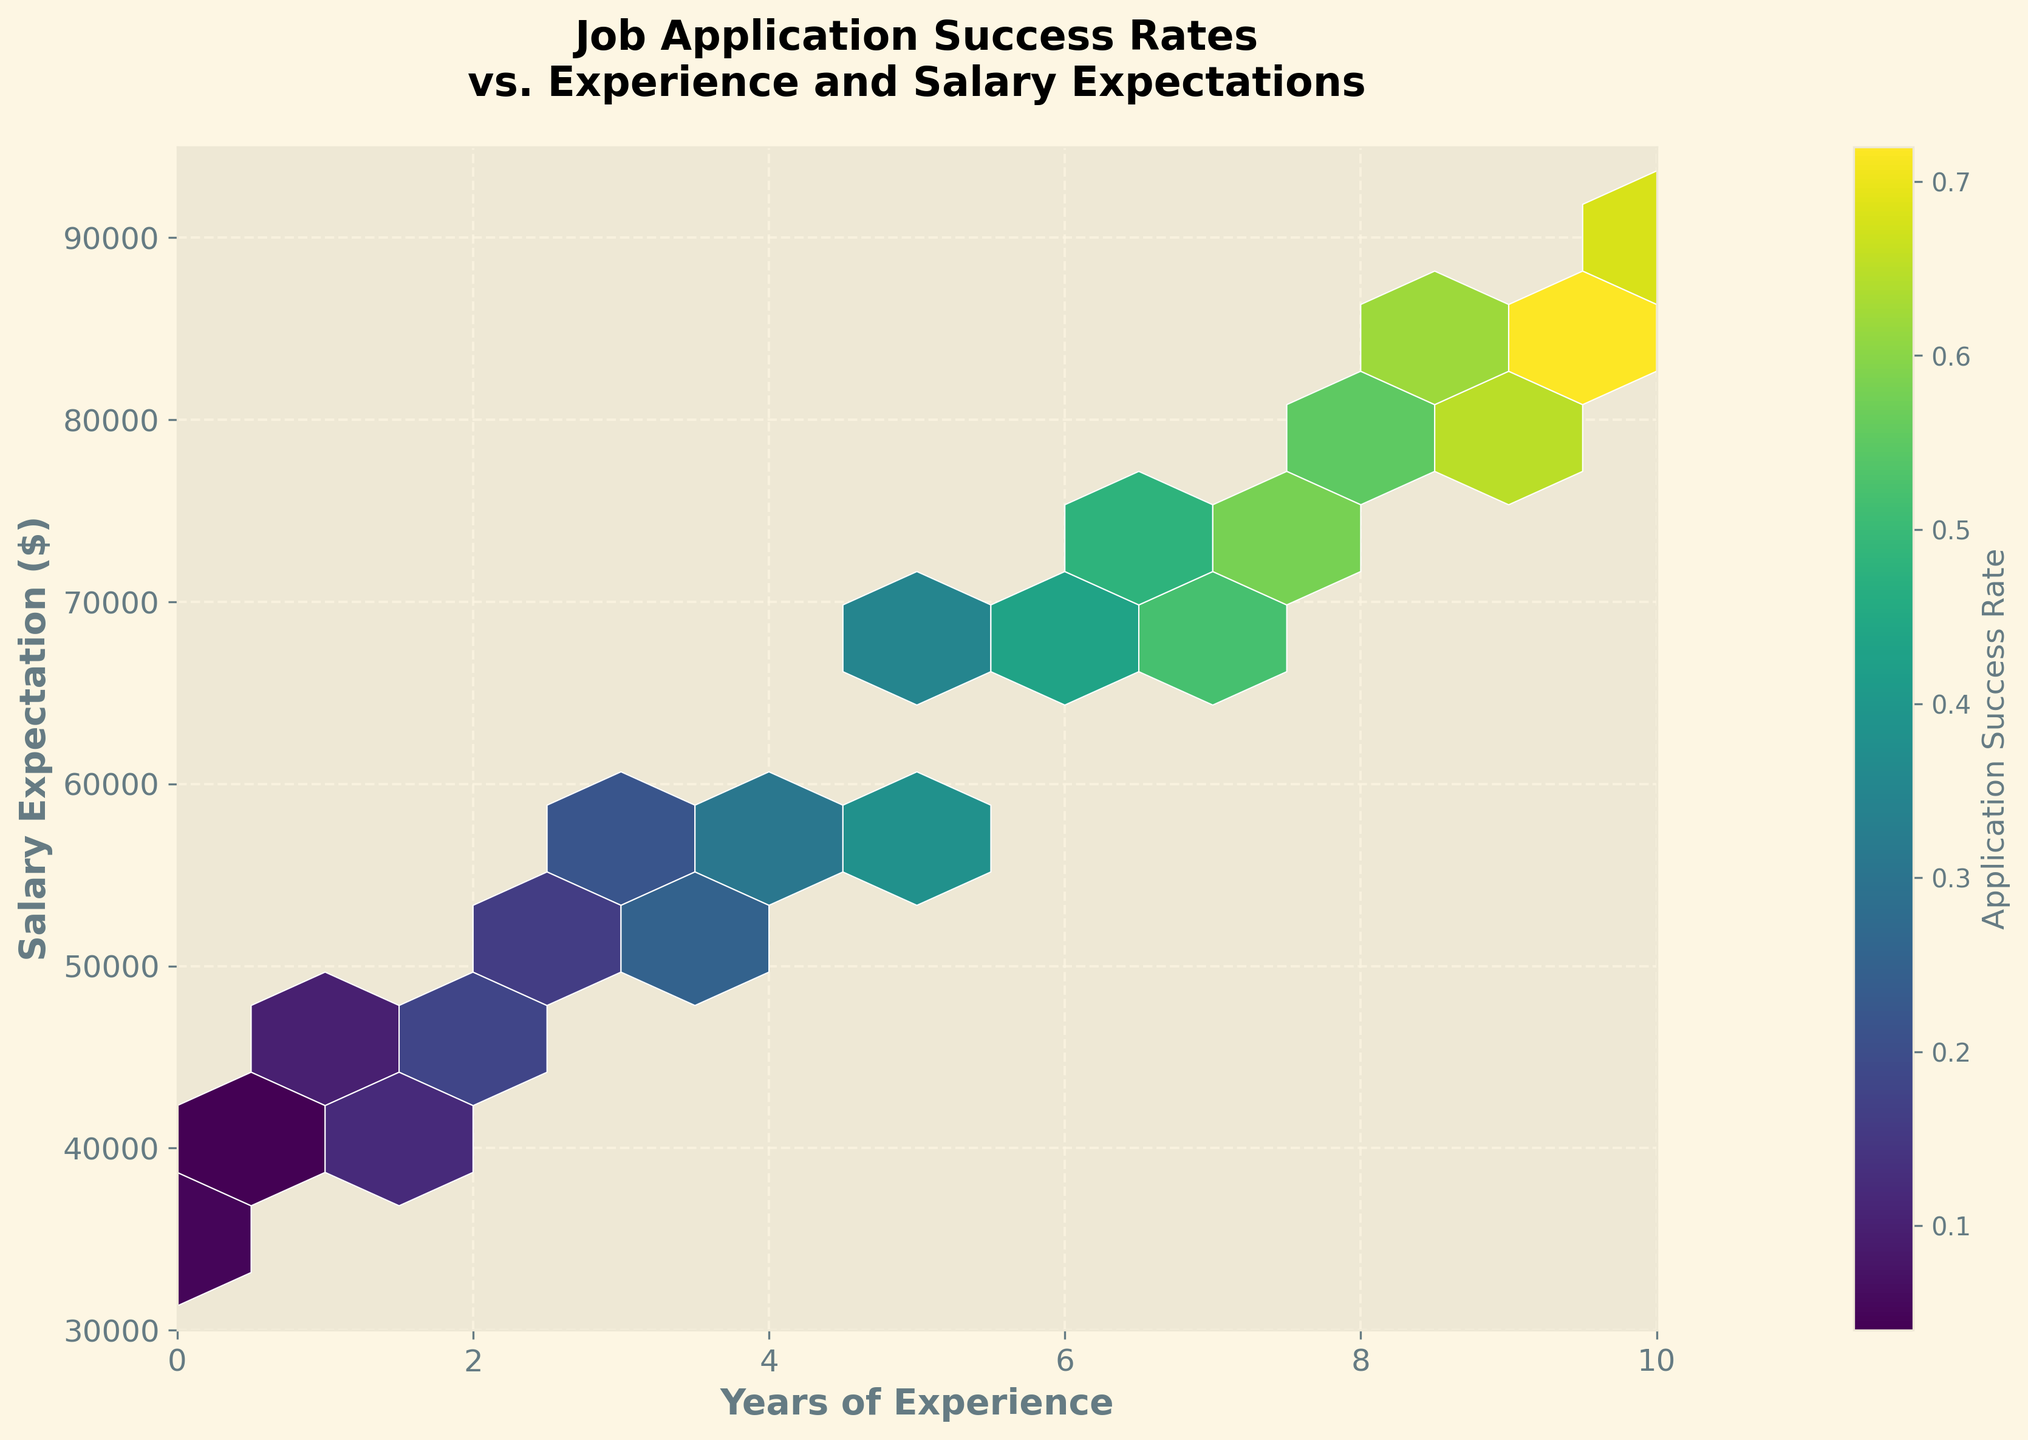What is the title of the plot? The title of the plot is displayed at the top of the figure in bold, large fonts. It helps to understand the main subject of the visualization.
Answer: Job Application Success Rates vs. Experience and Salary Expectations What are the labels of the x-axis and y-axis? The x-axis and y-axis labels are positioned along their respective axes and describe the variables being plotted.
Answer: Years of Experience (x-axis), Salary Expectation ($) (y-axis) What color scale is used in the hexbin plot? The color scale or colormap used in a hexbin plot helps indicate the magnitude of the third variable—in this case, the application success rate.
Answer: viridis What is the range of years of experience in the plot? The x-axis range provides the minimum and maximum values for the years of experience. The axis labels show it.
Answer: 0 to 10 years What is the minimum application success rate shown on the color bar? The color bar on the right side of the figure shows the range of application success rates represented by the color gradients. The lowest value on this bar indicates the minimum success rate.
Answer: 0.04 Which salary expectation range has the highest application success rates for people with 10 years of experience? By examining the hex within the plot where the x-axis equals 10 years of experience, we identify the corresponding color indicating the highest application success rate on the y-axis for salary expectations.
Answer: $85,000 to $90,000 Between which years of experience is there a noticeable increase in application success rates? By observing the changes in color intensity along the x-axis, we can see where the application success rates start to increase drastically.
Answer: Between 6 to 8 years What salary expectation had the highest concentration of application success rates for those with 5 years of experience? Look at the data points where the x-value is 5 years of experience and identify the densest hex, indicated by more vibrant colors or greater intensity.
Answer: $60,000 to $65,000 Is there any instance where a higher salary expectation corresponds to a lower application success rate within the same experience level? Compare the color intensities of hexes vertically within the same value of experience on the x-axis to spot if the color corresponding to lower success rates appears for higher salary expectations.
Answer: Yes Does the application success rate increase with years of experience in general, based on the data shown? Examine the overall trend by moving from left to right along the x-axis and observing how the color indicative of application success rate changes.
Answer: Yes 